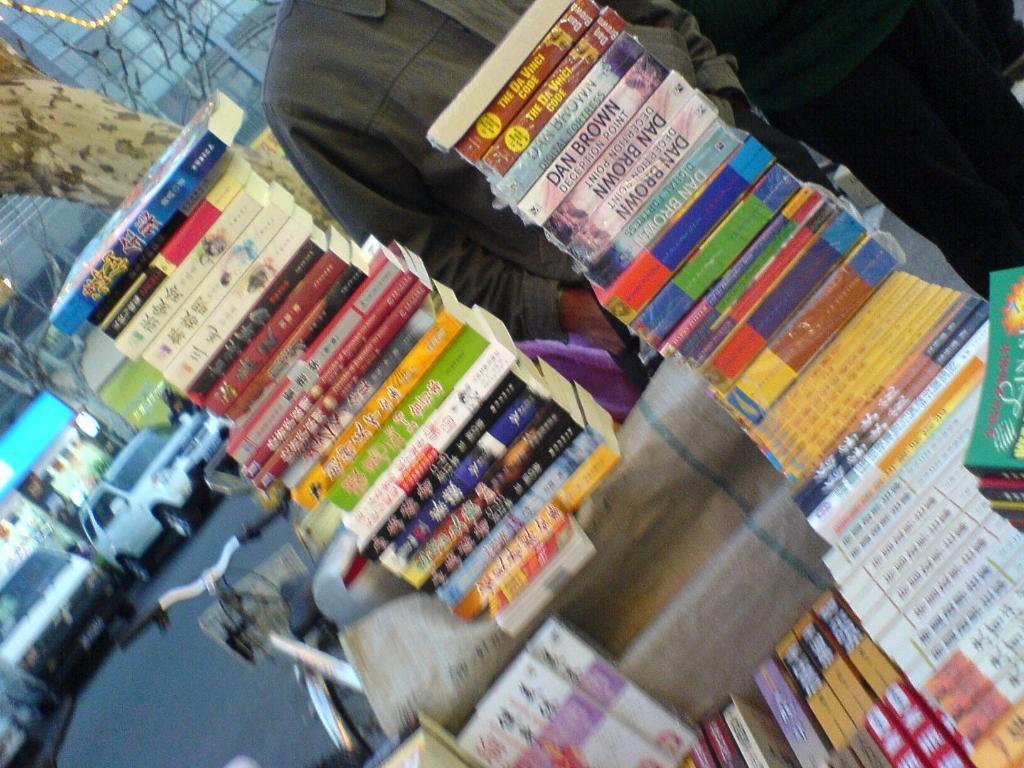<image>
Create a compact narrative representing the image presented. Stacks of books including the Da Vinci Code and Deception Point by Dan Brown. 